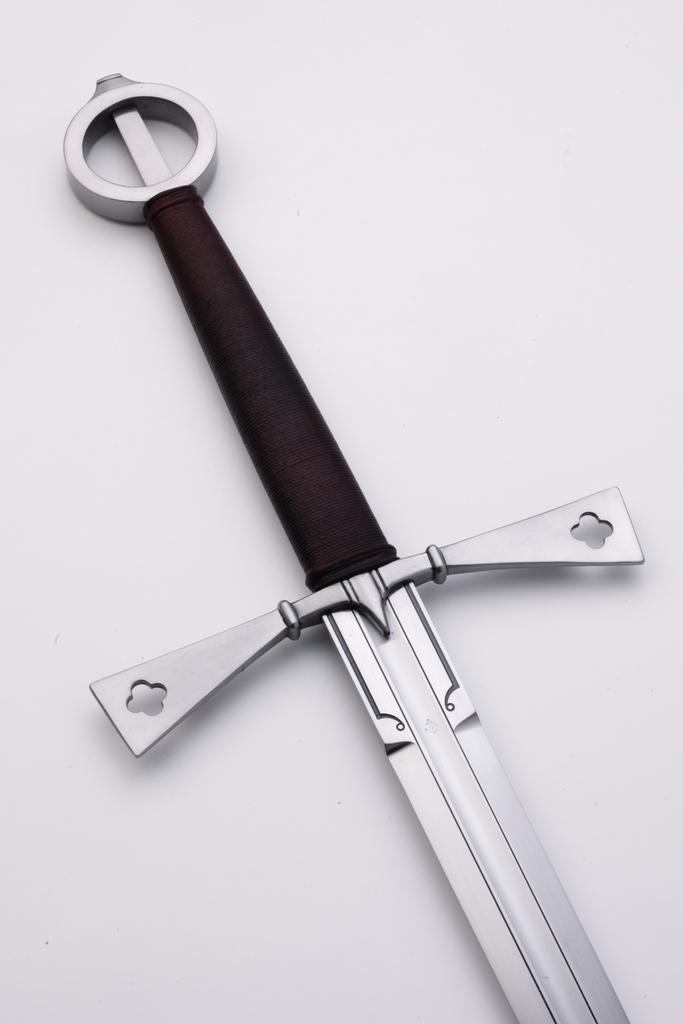How would you summarize this image in a sentence or two? In this image there is a sword on a surface. At the top there is the pommel to the sword. In the center there is a guard to the sword. Between it there is the grip. 